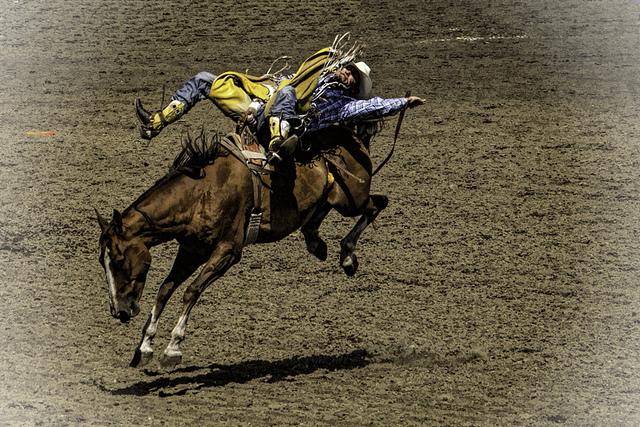What is the horse doing?
Short answer required. Bucking. Is the horse on a leash?
Quick response, please. No. Does this rider appear to be calmly riding the horse?
Concise answer only. No. Will the man fall?
Give a very brief answer. Yes. 